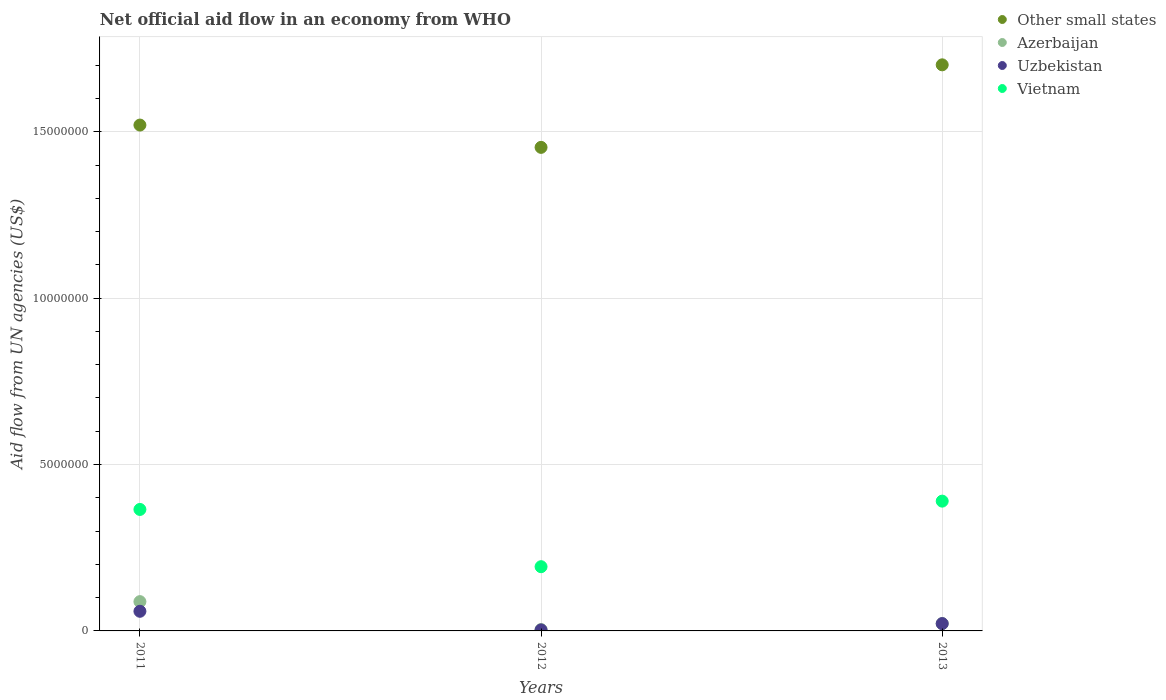How many different coloured dotlines are there?
Your response must be concise. 4. Is the number of dotlines equal to the number of legend labels?
Provide a short and direct response. Yes. What is the net official aid flow in Other small states in 2011?
Your answer should be compact. 1.52e+07. Across all years, what is the maximum net official aid flow in Other small states?
Make the answer very short. 1.70e+07. Across all years, what is the minimum net official aid flow in Vietnam?
Your response must be concise. 1.93e+06. In which year was the net official aid flow in Vietnam minimum?
Make the answer very short. 2012. What is the total net official aid flow in Azerbaijan in the graph?
Keep it short and to the point. 1.14e+06. What is the difference between the net official aid flow in Vietnam in 2012 and that in 2013?
Offer a terse response. -1.97e+06. What is the difference between the net official aid flow in Azerbaijan in 2013 and the net official aid flow in Vietnam in 2012?
Your answer should be compact. -1.71e+06. What is the average net official aid flow in Azerbaijan per year?
Offer a terse response. 3.80e+05. In the year 2012, what is the difference between the net official aid flow in Other small states and net official aid flow in Azerbaijan?
Provide a succinct answer. 1.45e+07. In how many years, is the net official aid flow in Other small states greater than 4000000 US$?
Offer a terse response. 3. What is the ratio of the net official aid flow in Uzbekistan in 2011 to that in 2013?
Provide a short and direct response. 2.68. Is the difference between the net official aid flow in Other small states in 2011 and 2012 greater than the difference between the net official aid flow in Azerbaijan in 2011 and 2012?
Provide a succinct answer. No. What is the difference between the highest and the second highest net official aid flow in Azerbaijan?
Your answer should be very brief. 6.60e+05. What is the difference between the highest and the lowest net official aid flow in Other small states?
Offer a very short reply. 2.48e+06. In how many years, is the net official aid flow in Azerbaijan greater than the average net official aid flow in Azerbaijan taken over all years?
Offer a terse response. 1. Is the sum of the net official aid flow in Other small states in 2011 and 2012 greater than the maximum net official aid flow in Azerbaijan across all years?
Offer a very short reply. Yes. Is it the case that in every year, the sum of the net official aid flow in Uzbekistan and net official aid flow in Vietnam  is greater than the sum of net official aid flow in Other small states and net official aid flow in Azerbaijan?
Your answer should be very brief. Yes. Is it the case that in every year, the sum of the net official aid flow in Vietnam and net official aid flow in Azerbaijan  is greater than the net official aid flow in Uzbekistan?
Give a very brief answer. Yes. Does the net official aid flow in Vietnam monotonically increase over the years?
Your answer should be compact. No. How many years are there in the graph?
Offer a terse response. 3. What is the difference between two consecutive major ticks on the Y-axis?
Your answer should be very brief. 5.00e+06. Does the graph contain any zero values?
Your response must be concise. No. Does the graph contain grids?
Provide a short and direct response. Yes. Where does the legend appear in the graph?
Provide a short and direct response. Top right. How many legend labels are there?
Provide a short and direct response. 4. What is the title of the graph?
Your answer should be compact. Net official aid flow in an economy from WHO. What is the label or title of the Y-axis?
Offer a terse response. Aid flow from UN agencies (US$). What is the Aid flow from UN agencies (US$) of Other small states in 2011?
Ensure brevity in your answer.  1.52e+07. What is the Aid flow from UN agencies (US$) in Azerbaijan in 2011?
Provide a short and direct response. 8.80e+05. What is the Aid flow from UN agencies (US$) in Uzbekistan in 2011?
Provide a succinct answer. 5.90e+05. What is the Aid flow from UN agencies (US$) in Vietnam in 2011?
Your answer should be compact. 3.65e+06. What is the Aid flow from UN agencies (US$) of Other small states in 2012?
Your answer should be very brief. 1.45e+07. What is the Aid flow from UN agencies (US$) of Vietnam in 2012?
Ensure brevity in your answer.  1.93e+06. What is the Aid flow from UN agencies (US$) of Other small states in 2013?
Your answer should be very brief. 1.70e+07. What is the Aid flow from UN agencies (US$) in Azerbaijan in 2013?
Make the answer very short. 2.20e+05. What is the Aid flow from UN agencies (US$) in Uzbekistan in 2013?
Your answer should be very brief. 2.20e+05. What is the Aid flow from UN agencies (US$) of Vietnam in 2013?
Your answer should be compact. 3.90e+06. Across all years, what is the maximum Aid flow from UN agencies (US$) in Other small states?
Offer a very short reply. 1.70e+07. Across all years, what is the maximum Aid flow from UN agencies (US$) in Azerbaijan?
Offer a terse response. 8.80e+05. Across all years, what is the maximum Aid flow from UN agencies (US$) of Uzbekistan?
Your response must be concise. 5.90e+05. Across all years, what is the maximum Aid flow from UN agencies (US$) in Vietnam?
Offer a very short reply. 3.90e+06. Across all years, what is the minimum Aid flow from UN agencies (US$) of Other small states?
Offer a very short reply. 1.45e+07. Across all years, what is the minimum Aid flow from UN agencies (US$) in Azerbaijan?
Provide a short and direct response. 4.00e+04. Across all years, what is the minimum Aid flow from UN agencies (US$) of Uzbekistan?
Provide a succinct answer. 3.00e+04. Across all years, what is the minimum Aid flow from UN agencies (US$) in Vietnam?
Provide a succinct answer. 1.93e+06. What is the total Aid flow from UN agencies (US$) of Other small states in the graph?
Offer a very short reply. 4.67e+07. What is the total Aid flow from UN agencies (US$) in Azerbaijan in the graph?
Keep it short and to the point. 1.14e+06. What is the total Aid flow from UN agencies (US$) in Uzbekistan in the graph?
Offer a very short reply. 8.40e+05. What is the total Aid flow from UN agencies (US$) in Vietnam in the graph?
Give a very brief answer. 9.48e+06. What is the difference between the Aid flow from UN agencies (US$) in Other small states in 2011 and that in 2012?
Keep it short and to the point. 6.70e+05. What is the difference between the Aid flow from UN agencies (US$) in Azerbaijan in 2011 and that in 2012?
Provide a succinct answer. 8.40e+05. What is the difference between the Aid flow from UN agencies (US$) in Uzbekistan in 2011 and that in 2012?
Offer a terse response. 5.60e+05. What is the difference between the Aid flow from UN agencies (US$) of Vietnam in 2011 and that in 2012?
Keep it short and to the point. 1.72e+06. What is the difference between the Aid flow from UN agencies (US$) in Other small states in 2011 and that in 2013?
Provide a short and direct response. -1.81e+06. What is the difference between the Aid flow from UN agencies (US$) of Uzbekistan in 2011 and that in 2013?
Provide a short and direct response. 3.70e+05. What is the difference between the Aid flow from UN agencies (US$) in Vietnam in 2011 and that in 2013?
Offer a very short reply. -2.50e+05. What is the difference between the Aid flow from UN agencies (US$) of Other small states in 2012 and that in 2013?
Ensure brevity in your answer.  -2.48e+06. What is the difference between the Aid flow from UN agencies (US$) in Azerbaijan in 2012 and that in 2013?
Make the answer very short. -1.80e+05. What is the difference between the Aid flow from UN agencies (US$) of Vietnam in 2012 and that in 2013?
Keep it short and to the point. -1.97e+06. What is the difference between the Aid flow from UN agencies (US$) in Other small states in 2011 and the Aid flow from UN agencies (US$) in Azerbaijan in 2012?
Your answer should be compact. 1.52e+07. What is the difference between the Aid flow from UN agencies (US$) in Other small states in 2011 and the Aid flow from UN agencies (US$) in Uzbekistan in 2012?
Offer a very short reply. 1.52e+07. What is the difference between the Aid flow from UN agencies (US$) of Other small states in 2011 and the Aid flow from UN agencies (US$) of Vietnam in 2012?
Offer a very short reply. 1.33e+07. What is the difference between the Aid flow from UN agencies (US$) of Azerbaijan in 2011 and the Aid flow from UN agencies (US$) of Uzbekistan in 2012?
Your response must be concise. 8.50e+05. What is the difference between the Aid flow from UN agencies (US$) of Azerbaijan in 2011 and the Aid flow from UN agencies (US$) of Vietnam in 2012?
Ensure brevity in your answer.  -1.05e+06. What is the difference between the Aid flow from UN agencies (US$) in Uzbekistan in 2011 and the Aid flow from UN agencies (US$) in Vietnam in 2012?
Make the answer very short. -1.34e+06. What is the difference between the Aid flow from UN agencies (US$) in Other small states in 2011 and the Aid flow from UN agencies (US$) in Azerbaijan in 2013?
Provide a short and direct response. 1.50e+07. What is the difference between the Aid flow from UN agencies (US$) in Other small states in 2011 and the Aid flow from UN agencies (US$) in Uzbekistan in 2013?
Offer a terse response. 1.50e+07. What is the difference between the Aid flow from UN agencies (US$) of Other small states in 2011 and the Aid flow from UN agencies (US$) of Vietnam in 2013?
Offer a terse response. 1.13e+07. What is the difference between the Aid flow from UN agencies (US$) of Azerbaijan in 2011 and the Aid flow from UN agencies (US$) of Vietnam in 2013?
Provide a succinct answer. -3.02e+06. What is the difference between the Aid flow from UN agencies (US$) in Uzbekistan in 2011 and the Aid flow from UN agencies (US$) in Vietnam in 2013?
Ensure brevity in your answer.  -3.31e+06. What is the difference between the Aid flow from UN agencies (US$) in Other small states in 2012 and the Aid flow from UN agencies (US$) in Azerbaijan in 2013?
Your response must be concise. 1.43e+07. What is the difference between the Aid flow from UN agencies (US$) in Other small states in 2012 and the Aid flow from UN agencies (US$) in Uzbekistan in 2013?
Your response must be concise. 1.43e+07. What is the difference between the Aid flow from UN agencies (US$) of Other small states in 2012 and the Aid flow from UN agencies (US$) of Vietnam in 2013?
Give a very brief answer. 1.06e+07. What is the difference between the Aid flow from UN agencies (US$) of Azerbaijan in 2012 and the Aid flow from UN agencies (US$) of Vietnam in 2013?
Provide a short and direct response. -3.86e+06. What is the difference between the Aid flow from UN agencies (US$) in Uzbekistan in 2012 and the Aid flow from UN agencies (US$) in Vietnam in 2013?
Keep it short and to the point. -3.87e+06. What is the average Aid flow from UN agencies (US$) in Other small states per year?
Keep it short and to the point. 1.56e+07. What is the average Aid flow from UN agencies (US$) of Azerbaijan per year?
Your response must be concise. 3.80e+05. What is the average Aid flow from UN agencies (US$) in Uzbekistan per year?
Make the answer very short. 2.80e+05. What is the average Aid flow from UN agencies (US$) of Vietnam per year?
Your response must be concise. 3.16e+06. In the year 2011, what is the difference between the Aid flow from UN agencies (US$) of Other small states and Aid flow from UN agencies (US$) of Azerbaijan?
Offer a terse response. 1.43e+07. In the year 2011, what is the difference between the Aid flow from UN agencies (US$) in Other small states and Aid flow from UN agencies (US$) in Uzbekistan?
Keep it short and to the point. 1.46e+07. In the year 2011, what is the difference between the Aid flow from UN agencies (US$) in Other small states and Aid flow from UN agencies (US$) in Vietnam?
Offer a terse response. 1.16e+07. In the year 2011, what is the difference between the Aid flow from UN agencies (US$) of Azerbaijan and Aid flow from UN agencies (US$) of Vietnam?
Make the answer very short. -2.77e+06. In the year 2011, what is the difference between the Aid flow from UN agencies (US$) in Uzbekistan and Aid flow from UN agencies (US$) in Vietnam?
Provide a short and direct response. -3.06e+06. In the year 2012, what is the difference between the Aid flow from UN agencies (US$) in Other small states and Aid flow from UN agencies (US$) in Azerbaijan?
Give a very brief answer. 1.45e+07. In the year 2012, what is the difference between the Aid flow from UN agencies (US$) in Other small states and Aid flow from UN agencies (US$) in Uzbekistan?
Your answer should be compact. 1.45e+07. In the year 2012, what is the difference between the Aid flow from UN agencies (US$) in Other small states and Aid flow from UN agencies (US$) in Vietnam?
Your answer should be very brief. 1.26e+07. In the year 2012, what is the difference between the Aid flow from UN agencies (US$) of Azerbaijan and Aid flow from UN agencies (US$) of Vietnam?
Offer a terse response. -1.89e+06. In the year 2012, what is the difference between the Aid flow from UN agencies (US$) in Uzbekistan and Aid flow from UN agencies (US$) in Vietnam?
Offer a very short reply. -1.90e+06. In the year 2013, what is the difference between the Aid flow from UN agencies (US$) in Other small states and Aid flow from UN agencies (US$) in Azerbaijan?
Provide a short and direct response. 1.68e+07. In the year 2013, what is the difference between the Aid flow from UN agencies (US$) of Other small states and Aid flow from UN agencies (US$) of Uzbekistan?
Make the answer very short. 1.68e+07. In the year 2013, what is the difference between the Aid flow from UN agencies (US$) of Other small states and Aid flow from UN agencies (US$) of Vietnam?
Provide a short and direct response. 1.31e+07. In the year 2013, what is the difference between the Aid flow from UN agencies (US$) of Azerbaijan and Aid flow from UN agencies (US$) of Vietnam?
Your answer should be very brief. -3.68e+06. In the year 2013, what is the difference between the Aid flow from UN agencies (US$) of Uzbekistan and Aid flow from UN agencies (US$) of Vietnam?
Offer a terse response. -3.68e+06. What is the ratio of the Aid flow from UN agencies (US$) in Other small states in 2011 to that in 2012?
Provide a short and direct response. 1.05. What is the ratio of the Aid flow from UN agencies (US$) in Azerbaijan in 2011 to that in 2012?
Your answer should be compact. 22. What is the ratio of the Aid flow from UN agencies (US$) of Uzbekistan in 2011 to that in 2012?
Offer a very short reply. 19.67. What is the ratio of the Aid flow from UN agencies (US$) in Vietnam in 2011 to that in 2012?
Provide a short and direct response. 1.89. What is the ratio of the Aid flow from UN agencies (US$) in Other small states in 2011 to that in 2013?
Give a very brief answer. 0.89. What is the ratio of the Aid flow from UN agencies (US$) in Uzbekistan in 2011 to that in 2013?
Offer a very short reply. 2.68. What is the ratio of the Aid flow from UN agencies (US$) in Vietnam in 2011 to that in 2013?
Your response must be concise. 0.94. What is the ratio of the Aid flow from UN agencies (US$) in Other small states in 2012 to that in 2013?
Your answer should be compact. 0.85. What is the ratio of the Aid flow from UN agencies (US$) in Azerbaijan in 2012 to that in 2013?
Give a very brief answer. 0.18. What is the ratio of the Aid flow from UN agencies (US$) in Uzbekistan in 2012 to that in 2013?
Ensure brevity in your answer.  0.14. What is the ratio of the Aid flow from UN agencies (US$) in Vietnam in 2012 to that in 2013?
Your answer should be very brief. 0.49. What is the difference between the highest and the second highest Aid flow from UN agencies (US$) in Other small states?
Your response must be concise. 1.81e+06. What is the difference between the highest and the lowest Aid flow from UN agencies (US$) in Other small states?
Your answer should be compact. 2.48e+06. What is the difference between the highest and the lowest Aid flow from UN agencies (US$) in Azerbaijan?
Offer a very short reply. 8.40e+05. What is the difference between the highest and the lowest Aid flow from UN agencies (US$) of Uzbekistan?
Ensure brevity in your answer.  5.60e+05. What is the difference between the highest and the lowest Aid flow from UN agencies (US$) of Vietnam?
Provide a succinct answer. 1.97e+06. 